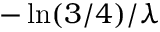<formula> <loc_0><loc_0><loc_500><loc_500>- \ln ( 3 / 4 ) / \lambda</formula> 